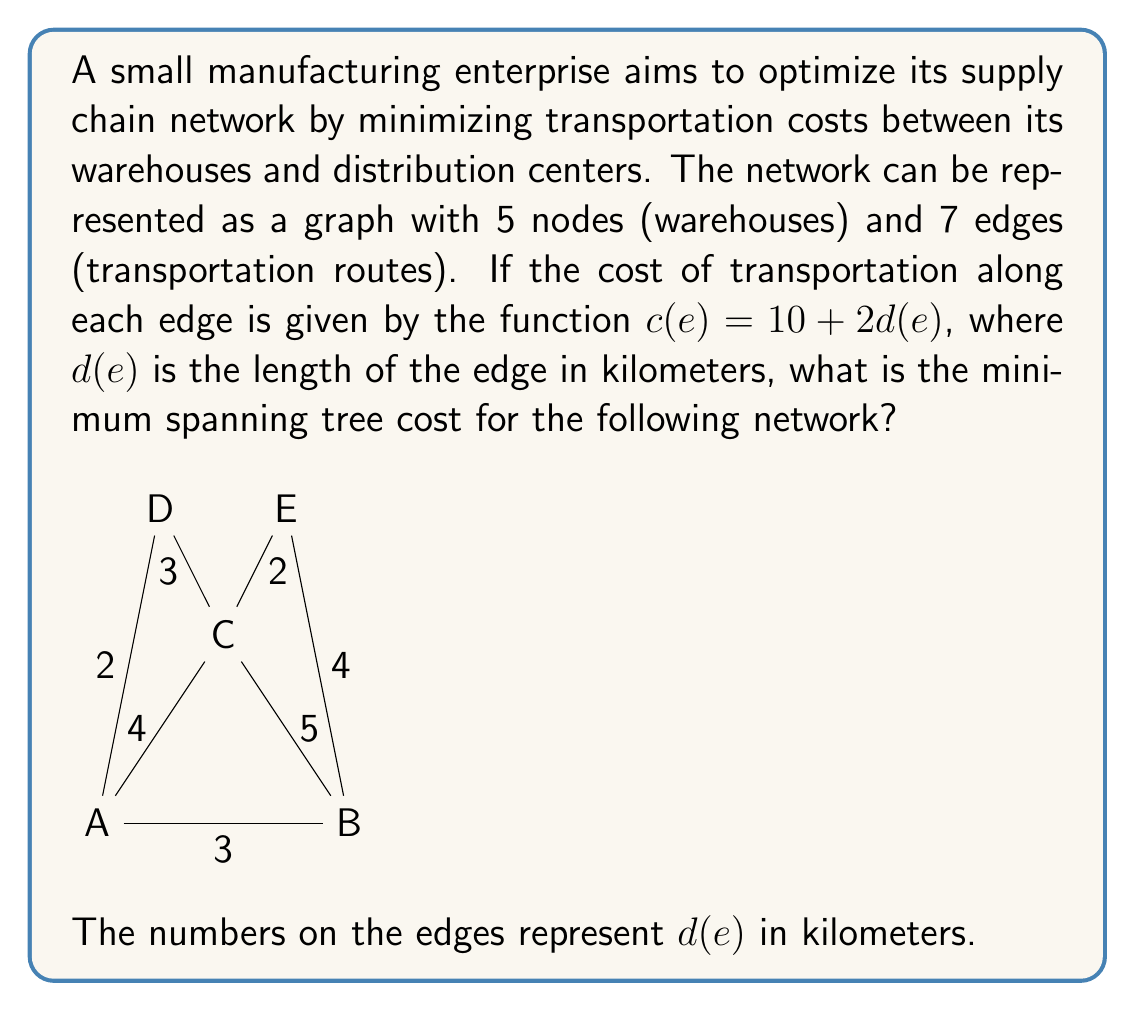Show me your answer to this math problem. To solve this problem, we'll follow these steps:

1) First, we need to calculate the cost for each edge using the given function $c(e) = 10 + 2d(e)$:

   A-B: $c(AB) = 10 + 2(3) = 16$
   A-C: $c(AC) = 10 + 2(4) = 18$
   B-C: $c(BC) = 10 + 2(5) = 20$
   A-D: $c(AD) = 10 + 2(2) = 14$
   C-D: $c(CD) = 10 + 2(3) = 16$
   C-E: $c(CE) = 10 + 2(2) = 14$
   B-E: $c(BE) = 10 + 2(4) = 18$

2) Now that we have the costs, we can apply Kruskal's algorithm to find the minimum spanning tree:

   - Sort the edges by cost in ascending order:
     AD (14), CE (14), AB (16), CD (16), AC (18), BE (18), BC (20)

   - Start adding edges to the tree, skipping those that would create a cycle:
     AD (14)
     CE (14)
     AB (16)
     CD (16)

3) After adding these four edges, we have connected all five nodes without creating any cycles. This forms our minimum spanning tree.

4) The total cost of the minimum spanning tree is the sum of the costs of these edges:

   $$14 + 14 + 16 + 16 = 60$$

This solution minimizes transportation costs while ensuring all warehouses are connected, which is crucial for efficient cash flow management in the supply chain.
Answer: The minimum spanning tree cost is $60. 